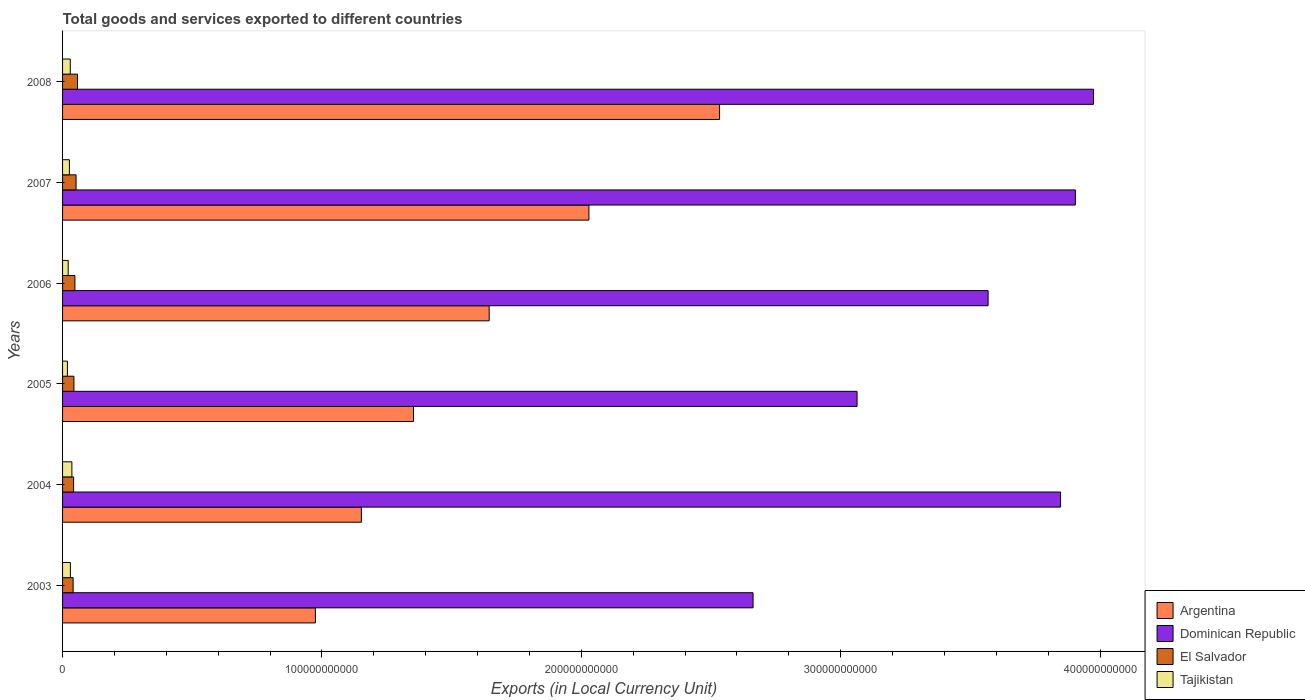How many different coloured bars are there?
Make the answer very short. 4. Are the number of bars per tick equal to the number of legend labels?
Your response must be concise. Yes. Are the number of bars on each tick of the Y-axis equal?
Keep it short and to the point. Yes. How many bars are there on the 2nd tick from the top?
Provide a short and direct response. 4. What is the label of the 3rd group of bars from the top?
Make the answer very short. 2006. What is the Amount of goods and services exports in El Salvador in 2007?
Your response must be concise. 5.20e+09. Across all years, what is the maximum Amount of goods and services exports in Dominican Republic?
Provide a succinct answer. 3.97e+11. Across all years, what is the minimum Amount of goods and services exports in El Salvador?
Offer a very short reply. 4.07e+09. What is the total Amount of goods and services exports in Tajikistan in the graph?
Offer a terse response. 1.63e+1. What is the difference between the Amount of goods and services exports in Dominican Republic in 2003 and that in 2005?
Offer a very short reply. -4.01e+1. What is the difference between the Amount of goods and services exports in El Salvador in 2005 and the Amount of goods and services exports in Argentina in 2007?
Ensure brevity in your answer.  -1.99e+11. What is the average Amount of goods and services exports in Tajikistan per year?
Provide a succinct answer. 2.71e+09. In the year 2007, what is the difference between the Amount of goods and services exports in Dominican Republic and Amount of goods and services exports in El Salvador?
Give a very brief answer. 3.85e+11. In how many years, is the Amount of goods and services exports in Tajikistan greater than 140000000000 LCU?
Ensure brevity in your answer.  0. What is the ratio of the Amount of goods and services exports in El Salvador in 2003 to that in 2005?
Ensure brevity in your answer.  0.93. What is the difference between the highest and the second highest Amount of goods and services exports in Argentina?
Your response must be concise. 5.04e+1. What is the difference between the highest and the lowest Amount of goods and services exports in Tajikistan?
Ensure brevity in your answer.  1.72e+09. In how many years, is the Amount of goods and services exports in Tajikistan greater than the average Amount of goods and services exports in Tajikistan taken over all years?
Your response must be concise. 3. Is the sum of the Amount of goods and services exports in Tajikistan in 2007 and 2008 greater than the maximum Amount of goods and services exports in El Salvador across all years?
Your response must be concise. No. What does the 2nd bar from the top in 2008 represents?
Make the answer very short. El Salvador. What does the 3rd bar from the bottom in 2003 represents?
Ensure brevity in your answer.  El Salvador. How many bars are there?
Make the answer very short. 24. How many years are there in the graph?
Your answer should be compact. 6. What is the difference between two consecutive major ticks on the X-axis?
Keep it short and to the point. 1.00e+11. Are the values on the major ticks of X-axis written in scientific E-notation?
Offer a terse response. No. What is the title of the graph?
Offer a terse response. Total goods and services exported to different countries. What is the label or title of the X-axis?
Give a very brief answer. Exports (in Local Currency Unit). What is the label or title of the Y-axis?
Your answer should be very brief. Years. What is the Exports (in Local Currency Unit) in Argentina in 2003?
Ensure brevity in your answer.  9.75e+1. What is the Exports (in Local Currency Unit) of Dominican Republic in 2003?
Provide a short and direct response. 2.66e+11. What is the Exports (in Local Currency Unit) of El Salvador in 2003?
Your answer should be compact. 4.07e+09. What is the Exports (in Local Currency Unit) of Tajikistan in 2003?
Your answer should be very brief. 3.02e+09. What is the Exports (in Local Currency Unit) of Argentina in 2004?
Make the answer very short. 1.15e+11. What is the Exports (in Local Currency Unit) in Dominican Republic in 2004?
Offer a terse response. 3.85e+11. What is the Exports (in Local Currency Unit) in El Salvador in 2004?
Ensure brevity in your answer.  4.26e+09. What is the Exports (in Local Currency Unit) in Tajikistan in 2004?
Offer a terse response. 3.60e+09. What is the Exports (in Local Currency Unit) in Argentina in 2005?
Provide a succinct answer. 1.35e+11. What is the Exports (in Local Currency Unit) in Dominican Republic in 2005?
Provide a short and direct response. 3.06e+11. What is the Exports (in Local Currency Unit) of El Salvador in 2005?
Give a very brief answer. 4.38e+09. What is the Exports (in Local Currency Unit) in Tajikistan in 2005?
Offer a very short reply. 1.87e+09. What is the Exports (in Local Currency Unit) in Argentina in 2006?
Offer a terse response. 1.64e+11. What is the Exports (in Local Currency Unit) in Dominican Republic in 2006?
Provide a succinct answer. 3.57e+11. What is the Exports (in Local Currency Unit) in El Salvador in 2006?
Offer a very short reply. 4.76e+09. What is the Exports (in Local Currency Unit) in Tajikistan in 2006?
Keep it short and to the point. 2.16e+09. What is the Exports (in Local Currency Unit) of Argentina in 2007?
Offer a terse response. 2.03e+11. What is the Exports (in Local Currency Unit) in Dominican Republic in 2007?
Your answer should be compact. 3.90e+11. What is the Exports (in Local Currency Unit) in El Salvador in 2007?
Ensure brevity in your answer.  5.20e+09. What is the Exports (in Local Currency Unit) in Tajikistan in 2007?
Make the answer very short. 2.64e+09. What is the Exports (in Local Currency Unit) of Argentina in 2008?
Your response must be concise. 2.53e+11. What is the Exports (in Local Currency Unit) of Dominican Republic in 2008?
Your response must be concise. 3.97e+11. What is the Exports (in Local Currency Unit) of El Salvador in 2008?
Your answer should be compact. 5.76e+09. What is the Exports (in Local Currency Unit) of Tajikistan in 2008?
Give a very brief answer. 2.97e+09. Across all years, what is the maximum Exports (in Local Currency Unit) of Argentina?
Provide a succinct answer. 2.53e+11. Across all years, what is the maximum Exports (in Local Currency Unit) of Dominican Republic?
Keep it short and to the point. 3.97e+11. Across all years, what is the maximum Exports (in Local Currency Unit) in El Salvador?
Provide a succinct answer. 5.76e+09. Across all years, what is the maximum Exports (in Local Currency Unit) in Tajikistan?
Give a very brief answer. 3.60e+09. Across all years, what is the minimum Exports (in Local Currency Unit) of Argentina?
Your answer should be very brief. 9.75e+1. Across all years, what is the minimum Exports (in Local Currency Unit) in Dominican Republic?
Your response must be concise. 2.66e+11. Across all years, what is the minimum Exports (in Local Currency Unit) of El Salvador?
Provide a succinct answer. 4.07e+09. Across all years, what is the minimum Exports (in Local Currency Unit) of Tajikistan?
Provide a short and direct response. 1.87e+09. What is the total Exports (in Local Currency Unit) of Argentina in the graph?
Provide a short and direct response. 9.69e+11. What is the total Exports (in Local Currency Unit) of Dominican Republic in the graph?
Provide a short and direct response. 2.10e+12. What is the total Exports (in Local Currency Unit) of El Salvador in the graph?
Your answer should be very brief. 2.84e+1. What is the total Exports (in Local Currency Unit) of Tajikistan in the graph?
Your answer should be compact. 1.63e+1. What is the difference between the Exports (in Local Currency Unit) in Argentina in 2003 and that in 2004?
Give a very brief answer. -1.77e+1. What is the difference between the Exports (in Local Currency Unit) in Dominican Republic in 2003 and that in 2004?
Your answer should be very brief. -1.19e+11. What is the difference between the Exports (in Local Currency Unit) of El Salvador in 2003 and that in 2004?
Provide a short and direct response. -1.86e+08. What is the difference between the Exports (in Local Currency Unit) in Tajikistan in 2003 and that in 2004?
Keep it short and to the point. -5.81e+08. What is the difference between the Exports (in Local Currency Unit) in Argentina in 2003 and that in 2005?
Provide a short and direct response. -3.78e+1. What is the difference between the Exports (in Local Currency Unit) in Dominican Republic in 2003 and that in 2005?
Offer a terse response. -4.01e+1. What is the difference between the Exports (in Local Currency Unit) of El Salvador in 2003 and that in 2005?
Your answer should be compact. -3.10e+08. What is the difference between the Exports (in Local Currency Unit) in Tajikistan in 2003 and that in 2005?
Keep it short and to the point. 1.14e+09. What is the difference between the Exports (in Local Currency Unit) in Argentina in 2003 and that in 2006?
Offer a very short reply. -6.70e+1. What is the difference between the Exports (in Local Currency Unit) in Dominican Republic in 2003 and that in 2006?
Offer a terse response. -9.06e+1. What is the difference between the Exports (in Local Currency Unit) in El Salvador in 2003 and that in 2006?
Give a very brief answer. -6.91e+08. What is the difference between the Exports (in Local Currency Unit) in Tajikistan in 2003 and that in 2006?
Offer a terse response. 8.51e+08. What is the difference between the Exports (in Local Currency Unit) of Argentina in 2003 and that in 2007?
Offer a terse response. -1.05e+11. What is the difference between the Exports (in Local Currency Unit) of Dominican Republic in 2003 and that in 2007?
Your answer should be very brief. -1.24e+11. What is the difference between the Exports (in Local Currency Unit) in El Salvador in 2003 and that in 2007?
Give a very brief answer. -1.13e+09. What is the difference between the Exports (in Local Currency Unit) in Tajikistan in 2003 and that in 2007?
Ensure brevity in your answer.  3.75e+08. What is the difference between the Exports (in Local Currency Unit) of Argentina in 2003 and that in 2008?
Give a very brief answer. -1.56e+11. What is the difference between the Exports (in Local Currency Unit) of Dominican Republic in 2003 and that in 2008?
Offer a very short reply. -1.31e+11. What is the difference between the Exports (in Local Currency Unit) of El Salvador in 2003 and that in 2008?
Offer a very short reply. -1.69e+09. What is the difference between the Exports (in Local Currency Unit) of Tajikistan in 2003 and that in 2008?
Your response must be concise. 4.79e+07. What is the difference between the Exports (in Local Currency Unit) of Argentina in 2004 and that in 2005?
Offer a very short reply. -2.01e+1. What is the difference between the Exports (in Local Currency Unit) of Dominican Republic in 2004 and that in 2005?
Provide a short and direct response. 7.85e+1. What is the difference between the Exports (in Local Currency Unit) in El Salvador in 2004 and that in 2005?
Keep it short and to the point. -1.24e+08. What is the difference between the Exports (in Local Currency Unit) in Tajikistan in 2004 and that in 2005?
Keep it short and to the point. 1.72e+09. What is the difference between the Exports (in Local Currency Unit) in Argentina in 2004 and that in 2006?
Provide a succinct answer. -4.93e+1. What is the difference between the Exports (in Local Currency Unit) in Dominican Republic in 2004 and that in 2006?
Your answer should be compact. 2.79e+1. What is the difference between the Exports (in Local Currency Unit) in El Salvador in 2004 and that in 2006?
Keep it short and to the point. -5.05e+08. What is the difference between the Exports (in Local Currency Unit) in Tajikistan in 2004 and that in 2006?
Provide a succinct answer. 1.43e+09. What is the difference between the Exports (in Local Currency Unit) of Argentina in 2004 and that in 2007?
Keep it short and to the point. -8.77e+1. What is the difference between the Exports (in Local Currency Unit) in Dominican Republic in 2004 and that in 2007?
Provide a succinct answer. -5.70e+09. What is the difference between the Exports (in Local Currency Unit) in El Salvador in 2004 and that in 2007?
Your answer should be compact. -9.45e+08. What is the difference between the Exports (in Local Currency Unit) of Tajikistan in 2004 and that in 2007?
Give a very brief answer. 9.56e+08. What is the difference between the Exports (in Local Currency Unit) of Argentina in 2004 and that in 2008?
Keep it short and to the point. -1.38e+11. What is the difference between the Exports (in Local Currency Unit) in Dominican Republic in 2004 and that in 2008?
Your answer should be compact. -1.27e+1. What is the difference between the Exports (in Local Currency Unit) of El Salvador in 2004 and that in 2008?
Offer a very short reply. -1.50e+09. What is the difference between the Exports (in Local Currency Unit) of Tajikistan in 2004 and that in 2008?
Keep it short and to the point. 6.29e+08. What is the difference between the Exports (in Local Currency Unit) in Argentina in 2005 and that in 2006?
Make the answer very short. -2.92e+1. What is the difference between the Exports (in Local Currency Unit) of Dominican Republic in 2005 and that in 2006?
Make the answer very short. -5.05e+1. What is the difference between the Exports (in Local Currency Unit) of El Salvador in 2005 and that in 2006?
Provide a succinct answer. -3.81e+08. What is the difference between the Exports (in Local Currency Unit) in Tajikistan in 2005 and that in 2006?
Provide a short and direct response. -2.91e+08. What is the difference between the Exports (in Local Currency Unit) of Argentina in 2005 and that in 2007?
Your response must be concise. -6.76e+1. What is the difference between the Exports (in Local Currency Unit) of Dominican Republic in 2005 and that in 2007?
Make the answer very short. -8.42e+1. What is the difference between the Exports (in Local Currency Unit) in El Salvador in 2005 and that in 2007?
Offer a very short reply. -8.21e+08. What is the difference between the Exports (in Local Currency Unit) of Tajikistan in 2005 and that in 2007?
Ensure brevity in your answer.  -7.66e+08. What is the difference between the Exports (in Local Currency Unit) of Argentina in 2005 and that in 2008?
Make the answer very short. -1.18e+11. What is the difference between the Exports (in Local Currency Unit) in Dominican Republic in 2005 and that in 2008?
Offer a very short reply. -9.12e+1. What is the difference between the Exports (in Local Currency Unit) of El Salvador in 2005 and that in 2008?
Offer a very short reply. -1.38e+09. What is the difference between the Exports (in Local Currency Unit) in Tajikistan in 2005 and that in 2008?
Your answer should be compact. -1.09e+09. What is the difference between the Exports (in Local Currency Unit) in Argentina in 2006 and that in 2007?
Your response must be concise. -3.84e+1. What is the difference between the Exports (in Local Currency Unit) in Dominican Republic in 2006 and that in 2007?
Offer a very short reply. -3.36e+1. What is the difference between the Exports (in Local Currency Unit) in El Salvador in 2006 and that in 2007?
Ensure brevity in your answer.  -4.40e+08. What is the difference between the Exports (in Local Currency Unit) in Tajikistan in 2006 and that in 2007?
Provide a succinct answer. -4.75e+08. What is the difference between the Exports (in Local Currency Unit) in Argentina in 2006 and that in 2008?
Offer a very short reply. -8.88e+1. What is the difference between the Exports (in Local Currency Unit) in Dominican Republic in 2006 and that in 2008?
Offer a very short reply. -4.06e+1. What is the difference between the Exports (in Local Currency Unit) of El Salvador in 2006 and that in 2008?
Offer a terse response. -9.97e+08. What is the difference between the Exports (in Local Currency Unit) of Tajikistan in 2006 and that in 2008?
Offer a terse response. -8.03e+08. What is the difference between the Exports (in Local Currency Unit) in Argentina in 2007 and that in 2008?
Your answer should be very brief. -5.04e+1. What is the difference between the Exports (in Local Currency Unit) of Dominican Republic in 2007 and that in 2008?
Give a very brief answer. -6.99e+09. What is the difference between the Exports (in Local Currency Unit) of El Salvador in 2007 and that in 2008?
Offer a very short reply. -5.57e+08. What is the difference between the Exports (in Local Currency Unit) of Tajikistan in 2007 and that in 2008?
Provide a short and direct response. -3.27e+08. What is the difference between the Exports (in Local Currency Unit) of Argentina in 2003 and the Exports (in Local Currency Unit) of Dominican Republic in 2004?
Keep it short and to the point. -2.87e+11. What is the difference between the Exports (in Local Currency Unit) of Argentina in 2003 and the Exports (in Local Currency Unit) of El Salvador in 2004?
Offer a very short reply. 9.32e+1. What is the difference between the Exports (in Local Currency Unit) in Argentina in 2003 and the Exports (in Local Currency Unit) in Tajikistan in 2004?
Your response must be concise. 9.39e+1. What is the difference between the Exports (in Local Currency Unit) of Dominican Republic in 2003 and the Exports (in Local Currency Unit) of El Salvador in 2004?
Keep it short and to the point. 2.62e+11. What is the difference between the Exports (in Local Currency Unit) of Dominican Republic in 2003 and the Exports (in Local Currency Unit) of Tajikistan in 2004?
Keep it short and to the point. 2.63e+11. What is the difference between the Exports (in Local Currency Unit) of El Salvador in 2003 and the Exports (in Local Currency Unit) of Tajikistan in 2004?
Your response must be concise. 4.77e+08. What is the difference between the Exports (in Local Currency Unit) of Argentina in 2003 and the Exports (in Local Currency Unit) of Dominican Republic in 2005?
Provide a short and direct response. -2.09e+11. What is the difference between the Exports (in Local Currency Unit) in Argentina in 2003 and the Exports (in Local Currency Unit) in El Salvador in 2005?
Your answer should be very brief. 9.31e+1. What is the difference between the Exports (in Local Currency Unit) in Argentina in 2003 and the Exports (in Local Currency Unit) in Tajikistan in 2005?
Your answer should be compact. 9.56e+1. What is the difference between the Exports (in Local Currency Unit) of Dominican Republic in 2003 and the Exports (in Local Currency Unit) of El Salvador in 2005?
Ensure brevity in your answer.  2.62e+11. What is the difference between the Exports (in Local Currency Unit) in Dominican Republic in 2003 and the Exports (in Local Currency Unit) in Tajikistan in 2005?
Keep it short and to the point. 2.64e+11. What is the difference between the Exports (in Local Currency Unit) of El Salvador in 2003 and the Exports (in Local Currency Unit) of Tajikistan in 2005?
Make the answer very short. 2.20e+09. What is the difference between the Exports (in Local Currency Unit) of Argentina in 2003 and the Exports (in Local Currency Unit) of Dominican Republic in 2006?
Offer a terse response. -2.59e+11. What is the difference between the Exports (in Local Currency Unit) of Argentina in 2003 and the Exports (in Local Currency Unit) of El Salvador in 2006?
Offer a terse response. 9.27e+1. What is the difference between the Exports (in Local Currency Unit) in Argentina in 2003 and the Exports (in Local Currency Unit) in Tajikistan in 2006?
Your response must be concise. 9.53e+1. What is the difference between the Exports (in Local Currency Unit) of Dominican Republic in 2003 and the Exports (in Local Currency Unit) of El Salvador in 2006?
Give a very brief answer. 2.61e+11. What is the difference between the Exports (in Local Currency Unit) of Dominican Republic in 2003 and the Exports (in Local Currency Unit) of Tajikistan in 2006?
Make the answer very short. 2.64e+11. What is the difference between the Exports (in Local Currency Unit) in El Salvador in 2003 and the Exports (in Local Currency Unit) in Tajikistan in 2006?
Your answer should be compact. 1.91e+09. What is the difference between the Exports (in Local Currency Unit) in Argentina in 2003 and the Exports (in Local Currency Unit) in Dominican Republic in 2007?
Keep it short and to the point. -2.93e+11. What is the difference between the Exports (in Local Currency Unit) in Argentina in 2003 and the Exports (in Local Currency Unit) in El Salvador in 2007?
Offer a very short reply. 9.23e+1. What is the difference between the Exports (in Local Currency Unit) in Argentina in 2003 and the Exports (in Local Currency Unit) in Tajikistan in 2007?
Offer a very short reply. 9.48e+1. What is the difference between the Exports (in Local Currency Unit) in Dominican Republic in 2003 and the Exports (in Local Currency Unit) in El Salvador in 2007?
Your response must be concise. 2.61e+11. What is the difference between the Exports (in Local Currency Unit) in Dominican Republic in 2003 and the Exports (in Local Currency Unit) in Tajikistan in 2007?
Your answer should be very brief. 2.64e+11. What is the difference between the Exports (in Local Currency Unit) in El Salvador in 2003 and the Exports (in Local Currency Unit) in Tajikistan in 2007?
Your response must be concise. 1.43e+09. What is the difference between the Exports (in Local Currency Unit) in Argentina in 2003 and the Exports (in Local Currency Unit) in Dominican Republic in 2008?
Offer a very short reply. -3.00e+11. What is the difference between the Exports (in Local Currency Unit) of Argentina in 2003 and the Exports (in Local Currency Unit) of El Salvador in 2008?
Your answer should be very brief. 9.17e+1. What is the difference between the Exports (in Local Currency Unit) of Argentina in 2003 and the Exports (in Local Currency Unit) of Tajikistan in 2008?
Provide a succinct answer. 9.45e+1. What is the difference between the Exports (in Local Currency Unit) of Dominican Republic in 2003 and the Exports (in Local Currency Unit) of El Salvador in 2008?
Your answer should be compact. 2.60e+11. What is the difference between the Exports (in Local Currency Unit) in Dominican Republic in 2003 and the Exports (in Local Currency Unit) in Tajikistan in 2008?
Provide a succinct answer. 2.63e+11. What is the difference between the Exports (in Local Currency Unit) in El Salvador in 2003 and the Exports (in Local Currency Unit) in Tajikistan in 2008?
Provide a short and direct response. 1.11e+09. What is the difference between the Exports (in Local Currency Unit) in Argentina in 2004 and the Exports (in Local Currency Unit) in Dominican Republic in 2005?
Give a very brief answer. -1.91e+11. What is the difference between the Exports (in Local Currency Unit) in Argentina in 2004 and the Exports (in Local Currency Unit) in El Salvador in 2005?
Offer a very short reply. 1.11e+11. What is the difference between the Exports (in Local Currency Unit) in Argentina in 2004 and the Exports (in Local Currency Unit) in Tajikistan in 2005?
Offer a very short reply. 1.13e+11. What is the difference between the Exports (in Local Currency Unit) in Dominican Republic in 2004 and the Exports (in Local Currency Unit) in El Salvador in 2005?
Ensure brevity in your answer.  3.80e+11. What is the difference between the Exports (in Local Currency Unit) of Dominican Republic in 2004 and the Exports (in Local Currency Unit) of Tajikistan in 2005?
Give a very brief answer. 3.83e+11. What is the difference between the Exports (in Local Currency Unit) in El Salvador in 2004 and the Exports (in Local Currency Unit) in Tajikistan in 2005?
Your answer should be very brief. 2.39e+09. What is the difference between the Exports (in Local Currency Unit) in Argentina in 2004 and the Exports (in Local Currency Unit) in Dominican Republic in 2006?
Your answer should be compact. -2.42e+11. What is the difference between the Exports (in Local Currency Unit) in Argentina in 2004 and the Exports (in Local Currency Unit) in El Salvador in 2006?
Your response must be concise. 1.10e+11. What is the difference between the Exports (in Local Currency Unit) of Argentina in 2004 and the Exports (in Local Currency Unit) of Tajikistan in 2006?
Make the answer very short. 1.13e+11. What is the difference between the Exports (in Local Currency Unit) of Dominican Republic in 2004 and the Exports (in Local Currency Unit) of El Salvador in 2006?
Your response must be concise. 3.80e+11. What is the difference between the Exports (in Local Currency Unit) of Dominican Republic in 2004 and the Exports (in Local Currency Unit) of Tajikistan in 2006?
Keep it short and to the point. 3.83e+11. What is the difference between the Exports (in Local Currency Unit) of El Salvador in 2004 and the Exports (in Local Currency Unit) of Tajikistan in 2006?
Your response must be concise. 2.09e+09. What is the difference between the Exports (in Local Currency Unit) in Argentina in 2004 and the Exports (in Local Currency Unit) in Dominican Republic in 2007?
Provide a succinct answer. -2.75e+11. What is the difference between the Exports (in Local Currency Unit) in Argentina in 2004 and the Exports (in Local Currency Unit) in El Salvador in 2007?
Your answer should be very brief. 1.10e+11. What is the difference between the Exports (in Local Currency Unit) of Argentina in 2004 and the Exports (in Local Currency Unit) of Tajikistan in 2007?
Ensure brevity in your answer.  1.13e+11. What is the difference between the Exports (in Local Currency Unit) in Dominican Republic in 2004 and the Exports (in Local Currency Unit) in El Salvador in 2007?
Ensure brevity in your answer.  3.80e+11. What is the difference between the Exports (in Local Currency Unit) of Dominican Republic in 2004 and the Exports (in Local Currency Unit) of Tajikistan in 2007?
Offer a very short reply. 3.82e+11. What is the difference between the Exports (in Local Currency Unit) of El Salvador in 2004 and the Exports (in Local Currency Unit) of Tajikistan in 2007?
Provide a succinct answer. 1.62e+09. What is the difference between the Exports (in Local Currency Unit) in Argentina in 2004 and the Exports (in Local Currency Unit) in Dominican Republic in 2008?
Provide a succinct answer. -2.82e+11. What is the difference between the Exports (in Local Currency Unit) in Argentina in 2004 and the Exports (in Local Currency Unit) in El Salvador in 2008?
Keep it short and to the point. 1.09e+11. What is the difference between the Exports (in Local Currency Unit) in Argentina in 2004 and the Exports (in Local Currency Unit) in Tajikistan in 2008?
Make the answer very short. 1.12e+11. What is the difference between the Exports (in Local Currency Unit) of Dominican Republic in 2004 and the Exports (in Local Currency Unit) of El Salvador in 2008?
Provide a short and direct response. 3.79e+11. What is the difference between the Exports (in Local Currency Unit) of Dominican Republic in 2004 and the Exports (in Local Currency Unit) of Tajikistan in 2008?
Provide a short and direct response. 3.82e+11. What is the difference between the Exports (in Local Currency Unit) of El Salvador in 2004 and the Exports (in Local Currency Unit) of Tajikistan in 2008?
Provide a succinct answer. 1.29e+09. What is the difference between the Exports (in Local Currency Unit) in Argentina in 2005 and the Exports (in Local Currency Unit) in Dominican Republic in 2006?
Provide a short and direct response. -2.22e+11. What is the difference between the Exports (in Local Currency Unit) in Argentina in 2005 and the Exports (in Local Currency Unit) in El Salvador in 2006?
Give a very brief answer. 1.31e+11. What is the difference between the Exports (in Local Currency Unit) in Argentina in 2005 and the Exports (in Local Currency Unit) in Tajikistan in 2006?
Ensure brevity in your answer.  1.33e+11. What is the difference between the Exports (in Local Currency Unit) of Dominican Republic in 2005 and the Exports (in Local Currency Unit) of El Salvador in 2006?
Make the answer very short. 3.02e+11. What is the difference between the Exports (in Local Currency Unit) of Dominican Republic in 2005 and the Exports (in Local Currency Unit) of Tajikistan in 2006?
Provide a succinct answer. 3.04e+11. What is the difference between the Exports (in Local Currency Unit) of El Salvador in 2005 and the Exports (in Local Currency Unit) of Tajikistan in 2006?
Your answer should be very brief. 2.22e+09. What is the difference between the Exports (in Local Currency Unit) of Argentina in 2005 and the Exports (in Local Currency Unit) of Dominican Republic in 2007?
Provide a succinct answer. -2.55e+11. What is the difference between the Exports (in Local Currency Unit) of Argentina in 2005 and the Exports (in Local Currency Unit) of El Salvador in 2007?
Make the answer very short. 1.30e+11. What is the difference between the Exports (in Local Currency Unit) of Argentina in 2005 and the Exports (in Local Currency Unit) of Tajikistan in 2007?
Provide a short and direct response. 1.33e+11. What is the difference between the Exports (in Local Currency Unit) of Dominican Republic in 2005 and the Exports (in Local Currency Unit) of El Salvador in 2007?
Provide a succinct answer. 3.01e+11. What is the difference between the Exports (in Local Currency Unit) in Dominican Republic in 2005 and the Exports (in Local Currency Unit) in Tajikistan in 2007?
Your answer should be compact. 3.04e+11. What is the difference between the Exports (in Local Currency Unit) of El Salvador in 2005 and the Exports (in Local Currency Unit) of Tajikistan in 2007?
Make the answer very short. 1.74e+09. What is the difference between the Exports (in Local Currency Unit) of Argentina in 2005 and the Exports (in Local Currency Unit) of Dominican Republic in 2008?
Give a very brief answer. -2.62e+11. What is the difference between the Exports (in Local Currency Unit) in Argentina in 2005 and the Exports (in Local Currency Unit) in El Salvador in 2008?
Give a very brief answer. 1.30e+11. What is the difference between the Exports (in Local Currency Unit) in Argentina in 2005 and the Exports (in Local Currency Unit) in Tajikistan in 2008?
Keep it short and to the point. 1.32e+11. What is the difference between the Exports (in Local Currency Unit) of Dominican Republic in 2005 and the Exports (in Local Currency Unit) of El Salvador in 2008?
Your response must be concise. 3.01e+11. What is the difference between the Exports (in Local Currency Unit) in Dominican Republic in 2005 and the Exports (in Local Currency Unit) in Tajikistan in 2008?
Ensure brevity in your answer.  3.03e+11. What is the difference between the Exports (in Local Currency Unit) of El Salvador in 2005 and the Exports (in Local Currency Unit) of Tajikistan in 2008?
Your answer should be compact. 1.42e+09. What is the difference between the Exports (in Local Currency Unit) of Argentina in 2006 and the Exports (in Local Currency Unit) of Dominican Republic in 2007?
Your answer should be compact. -2.26e+11. What is the difference between the Exports (in Local Currency Unit) in Argentina in 2006 and the Exports (in Local Currency Unit) in El Salvador in 2007?
Offer a terse response. 1.59e+11. What is the difference between the Exports (in Local Currency Unit) in Argentina in 2006 and the Exports (in Local Currency Unit) in Tajikistan in 2007?
Offer a very short reply. 1.62e+11. What is the difference between the Exports (in Local Currency Unit) in Dominican Republic in 2006 and the Exports (in Local Currency Unit) in El Salvador in 2007?
Your response must be concise. 3.52e+11. What is the difference between the Exports (in Local Currency Unit) in Dominican Republic in 2006 and the Exports (in Local Currency Unit) in Tajikistan in 2007?
Your answer should be very brief. 3.54e+11. What is the difference between the Exports (in Local Currency Unit) in El Salvador in 2006 and the Exports (in Local Currency Unit) in Tajikistan in 2007?
Give a very brief answer. 2.12e+09. What is the difference between the Exports (in Local Currency Unit) of Argentina in 2006 and the Exports (in Local Currency Unit) of Dominican Republic in 2008?
Keep it short and to the point. -2.33e+11. What is the difference between the Exports (in Local Currency Unit) in Argentina in 2006 and the Exports (in Local Currency Unit) in El Salvador in 2008?
Give a very brief answer. 1.59e+11. What is the difference between the Exports (in Local Currency Unit) in Argentina in 2006 and the Exports (in Local Currency Unit) in Tajikistan in 2008?
Your response must be concise. 1.62e+11. What is the difference between the Exports (in Local Currency Unit) of Dominican Republic in 2006 and the Exports (in Local Currency Unit) of El Salvador in 2008?
Keep it short and to the point. 3.51e+11. What is the difference between the Exports (in Local Currency Unit) in Dominican Republic in 2006 and the Exports (in Local Currency Unit) in Tajikistan in 2008?
Your answer should be compact. 3.54e+11. What is the difference between the Exports (in Local Currency Unit) in El Salvador in 2006 and the Exports (in Local Currency Unit) in Tajikistan in 2008?
Your answer should be very brief. 1.80e+09. What is the difference between the Exports (in Local Currency Unit) in Argentina in 2007 and the Exports (in Local Currency Unit) in Dominican Republic in 2008?
Offer a very short reply. -1.95e+11. What is the difference between the Exports (in Local Currency Unit) of Argentina in 2007 and the Exports (in Local Currency Unit) of El Salvador in 2008?
Give a very brief answer. 1.97e+11. What is the difference between the Exports (in Local Currency Unit) in Argentina in 2007 and the Exports (in Local Currency Unit) in Tajikistan in 2008?
Offer a terse response. 2.00e+11. What is the difference between the Exports (in Local Currency Unit) in Dominican Republic in 2007 and the Exports (in Local Currency Unit) in El Salvador in 2008?
Offer a terse response. 3.85e+11. What is the difference between the Exports (in Local Currency Unit) in Dominican Republic in 2007 and the Exports (in Local Currency Unit) in Tajikistan in 2008?
Offer a very short reply. 3.88e+11. What is the difference between the Exports (in Local Currency Unit) in El Salvador in 2007 and the Exports (in Local Currency Unit) in Tajikistan in 2008?
Your response must be concise. 2.24e+09. What is the average Exports (in Local Currency Unit) of Argentina per year?
Make the answer very short. 1.61e+11. What is the average Exports (in Local Currency Unit) of Dominican Republic per year?
Make the answer very short. 3.50e+11. What is the average Exports (in Local Currency Unit) of El Salvador per year?
Your answer should be compact. 4.74e+09. What is the average Exports (in Local Currency Unit) in Tajikistan per year?
Your response must be concise. 2.71e+09. In the year 2003, what is the difference between the Exports (in Local Currency Unit) in Argentina and Exports (in Local Currency Unit) in Dominican Republic?
Ensure brevity in your answer.  -1.69e+11. In the year 2003, what is the difference between the Exports (in Local Currency Unit) of Argentina and Exports (in Local Currency Unit) of El Salvador?
Give a very brief answer. 9.34e+1. In the year 2003, what is the difference between the Exports (in Local Currency Unit) of Argentina and Exports (in Local Currency Unit) of Tajikistan?
Your answer should be very brief. 9.45e+1. In the year 2003, what is the difference between the Exports (in Local Currency Unit) in Dominican Republic and Exports (in Local Currency Unit) in El Salvador?
Provide a short and direct response. 2.62e+11. In the year 2003, what is the difference between the Exports (in Local Currency Unit) in Dominican Republic and Exports (in Local Currency Unit) in Tajikistan?
Keep it short and to the point. 2.63e+11. In the year 2003, what is the difference between the Exports (in Local Currency Unit) in El Salvador and Exports (in Local Currency Unit) in Tajikistan?
Keep it short and to the point. 1.06e+09. In the year 2004, what is the difference between the Exports (in Local Currency Unit) in Argentina and Exports (in Local Currency Unit) in Dominican Republic?
Offer a terse response. -2.70e+11. In the year 2004, what is the difference between the Exports (in Local Currency Unit) in Argentina and Exports (in Local Currency Unit) in El Salvador?
Provide a succinct answer. 1.11e+11. In the year 2004, what is the difference between the Exports (in Local Currency Unit) of Argentina and Exports (in Local Currency Unit) of Tajikistan?
Keep it short and to the point. 1.12e+11. In the year 2004, what is the difference between the Exports (in Local Currency Unit) in Dominican Republic and Exports (in Local Currency Unit) in El Salvador?
Provide a short and direct response. 3.81e+11. In the year 2004, what is the difference between the Exports (in Local Currency Unit) of Dominican Republic and Exports (in Local Currency Unit) of Tajikistan?
Keep it short and to the point. 3.81e+11. In the year 2004, what is the difference between the Exports (in Local Currency Unit) in El Salvador and Exports (in Local Currency Unit) in Tajikistan?
Make the answer very short. 6.63e+08. In the year 2005, what is the difference between the Exports (in Local Currency Unit) of Argentina and Exports (in Local Currency Unit) of Dominican Republic?
Your answer should be compact. -1.71e+11. In the year 2005, what is the difference between the Exports (in Local Currency Unit) of Argentina and Exports (in Local Currency Unit) of El Salvador?
Provide a short and direct response. 1.31e+11. In the year 2005, what is the difference between the Exports (in Local Currency Unit) of Argentina and Exports (in Local Currency Unit) of Tajikistan?
Provide a succinct answer. 1.33e+11. In the year 2005, what is the difference between the Exports (in Local Currency Unit) in Dominican Republic and Exports (in Local Currency Unit) in El Salvador?
Offer a terse response. 3.02e+11. In the year 2005, what is the difference between the Exports (in Local Currency Unit) of Dominican Republic and Exports (in Local Currency Unit) of Tajikistan?
Give a very brief answer. 3.04e+11. In the year 2005, what is the difference between the Exports (in Local Currency Unit) in El Salvador and Exports (in Local Currency Unit) in Tajikistan?
Provide a short and direct response. 2.51e+09. In the year 2006, what is the difference between the Exports (in Local Currency Unit) in Argentina and Exports (in Local Currency Unit) in Dominican Republic?
Your response must be concise. -1.92e+11. In the year 2006, what is the difference between the Exports (in Local Currency Unit) in Argentina and Exports (in Local Currency Unit) in El Salvador?
Your answer should be very brief. 1.60e+11. In the year 2006, what is the difference between the Exports (in Local Currency Unit) of Argentina and Exports (in Local Currency Unit) of Tajikistan?
Offer a very short reply. 1.62e+11. In the year 2006, what is the difference between the Exports (in Local Currency Unit) in Dominican Republic and Exports (in Local Currency Unit) in El Salvador?
Your response must be concise. 3.52e+11. In the year 2006, what is the difference between the Exports (in Local Currency Unit) in Dominican Republic and Exports (in Local Currency Unit) in Tajikistan?
Ensure brevity in your answer.  3.55e+11. In the year 2006, what is the difference between the Exports (in Local Currency Unit) of El Salvador and Exports (in Local Currency Unit) of Tajikistan?
Your response must be concise. 2.60e+09. In the year 2007, what is the difference between the Exports (in Local Currency Unit) of Argentina and Exports (in Local Currency Unit) of Dominican Republic?
Provide a short and direct response. -1.88e+11. In the year 2007, what is the difference between the Exports (in Local Currency Unit) of Argentina and Exports (in Local Currency Unit) of El Salvador?
Make the answer very short. 1.98e+11. In the year 2007, what is the difference between the Exports (in Local Currency Unit) of Argentina and Exports (in Local Currency Unit) of Tajikistan?
Your answer should be very brief. 2.00e+11. In the year 2007, what is the difference between the Exports (in Local Currency Unit) of Dominican Republic and Exports (in Local Currency Unit) of El Salvador?
Offer a terse response. 3.85e+11. In the year 2007, what is the difference between the Exports (in Local Currency Unit) in Dominican Republic and Exports (in Local Currency Unit) in Tajikistan?
Provide a short and direct response. 3.88e+11. In the year 2007, what is the difference between the Exports (in Local Currency Unit) in El Salvador and Exports (in Local Currency Unit) in Tajikistan?
Offer a terse response. 2.56e+09. In the year 2008, what is the difference between the Exports (in Local Currency Unit) of Argentina and Exports (in Local Currency Unit) of Dominican Republic?
Ensure brevity in your answer.  -1.44e+11. In the year 2008, what is the difference between the Exports (in Local Currency Unit) of Argentina and Exports (in Local Currency Unit) of El Salvador?
Provide a succinct answer. 2.48e+11. In the year 2008, what is the difference between the Exports (in Local Currency Unit) in Argentina and Exports (in Local Currency Unit) in Tajikistan?
Offer a very short reply. 2.50e+11. In the year 2008, what is the difference between the Exports (in Local Currency Unit) in Dominican Republic and Exports (in Local Currency Unit) in El Salvador?
Your response must be concise. 3.92e+11. In the year 2008, what is the difference between the Exports (in Local Currency Unit) of Dominican Republic and Exports (in Local Currency Unit) of Tajikistan?
Offer a terse response. 3.95e+11. In the year 2008, what is the difference between the Exports (in Local Currency Unit) of El Salvador and Exports (in Local Currency Unit) of Tajikistan?
Your response must be concise. 2.79e+09. What is the ratio of the Exports (in Local Currency Unit) in Argentina in 2003 to that in 2004?
Give a very brief answer. 0.85. What is the ratio of the Exports (in Local Currency Unit) of Dominican Republic in 2003 to that in 2004?
Offer a terse response. 0.69. What is the ratio of the Exports (in Local Currency Unit) in El Salvador in 2003 to that in 2004?
Keep it short and to the point. 0.96. What is the ratio of the Exports (in Local Currency Unit) of Tajikistan in 2003 to that in 2004?
Make the answer very short. 0.84. What is the ratio of the Exports (in Local Currency Unit) in Argentina in 2003 to that in 2005?
Ensure brevity in your answer.  0.72. What is the ratio of the Exports (in Local Currency Unit) in Dominican Republic in 2003 to that in 2005?
Offer a terse response. 0.87. What is the ratio of the Exports (in Local Currency Unit) in El Salvador in 2003 to that in 2005?
Keep it short and to the point. 0.93. What is the ratio of the Exports (in Local Currency Unit) of Tajikistan in 2003 to that in 2005?
Your answer should be very brief. 1.61. What is the ratio of the Exports (in Local Currency Unit) in Argentina in 2003 to that in 2006?
Your answer should be very brief. 0.59. What is the ratio of the Exports (in Local Currency Unit) of Dominican Republic in 2003 to that in 2006?
Offer a very short reply. 0.75. What is the ratio of the Exports (in Local Currency Unit) of El Salvador in 2003 to that in 2006?
Your answer should be very brief. 0.85. What is the ratio of the Exports (in Local Currency Unit) of Tajikistan in 2003 to that in 2006?
Give a very brief answer. 1.39. What is the ratio of the Exports (in Local Currency Unit) in Argentina in 2003 to that in 2007?
Give a very brief answer. 0.48. What is the ratio of the Exports (in Local Currency Unit) of Dominican Republic in 2003 to that in 2007?
Offer a very short reply. 0.68. What is the ratio of the Exports (in Local Currency Unit) in El Salvador in 2003 to that in 2007?
Your response must be concise. 0.78. What is the ratio of the Exports (in Local Currency Unit) of Tajikistan in 2003 to that in 2007?
Offer a terse response. 1.14. What is the ratio of the Exports (in Local Currency Unit) of Argentina in 2003 to that in 2008?
Offer a very short reply. 0.38. What is the ratio of the Exports (in Local Currency Unit) in Dominican Republic in 2003 to that in 2008?
Provide a short and direct response. 0.67. What is the ratio of the Exports (in Local Currency Unit) in El Salvador in 2003 to that in 2008?
Your answer should be compact. 0.71. What is the ratio of the Exports (in Local Currency Unit) in Tajikistan in 2003 to that in 2008?
Provide a short and direct response. 1.02. What is the ratio of the Exports (in Local Currency Unit) in Argentina in 2004 to that in 2005?
Offer a terse response. 0.85. What is the ratio of the Exports (in Local Currency Unit) of Dominican Republic in 2004 to that in 2005?
Offer a terse response. 1.26. What is the ratio of the Exports (in Local Currency Unit) of El Salvador in 2004 to that in 2005?
Make the answer very short. 0.97. What is the ratio of the Exports (in Local Currency Unit) in Tajikistan in 2004 to that in 2005?
Your response must be concise. 1.92. What is the ratio of the Exports (in Local Currency Unit) of Argentina in 2004 to that in 2006?
Offer a very short reply. 0.7. What is the ratio of the Exports (in Local Currency Unit) in Dominican Republic in 2004 to that in 2006?
Make the answer very short. 1.08. What is the ratio of the Exports (in Local Currency Unit) of El Salvador in 2004 to that in 2006?
Your response must be concise. 0.89. What is the ratio of the Exports (in Local Currency Unit) of Tajikistan in 2004 to that in 2006?
Offer a terse response. 1.66. What is the ratio of the Exports (in Local Currency Unit) of Argentina in 2004 to that in 2007?
Provide a succinct answer. 0.57. What is the ratio of the Exports (in Local Currency Unit) of Dominican Republic in 2004 to that in 2007?
Offer a very short reply. 0.99. What is the ratio of the Exports (in Local Currency Unit) in El Salvador in 2004 to that in 2007?
Your response must be concise. 0.82. What is the ratio of the Exports (in Local Currency Unit) in Tajikistan in 2004 to that in 2007?
Keep it short and to the point. 1.36. What is the ratio of the Exports (in Local Currency Unit) in Argentina in 2004 to that in 2008?
Offer a very short reply. 0.45. What is the ratio of the Exports (in Local Currency Unit) in Dominican Republic in 2004 to that in 2008?
Provide a succinct answer. 0.97. What is the ratio of the Exports (in Local Currency Unit) of El Salvador in 2004 to that in 2008?
Provide a short and direct response. 0.74. What is the ratio of the Exports (in Local Currency Unit) of Tajikistan in 2004 to that in 2008?
Keep it short and to the point. 1.21. What is the ratio of the Exports (in Local Currency Unit) of Argentina in 2005 to that in 2006?
Ensure brevity in your answer.  0.82. What is the ratio of the Exports (in Local Currency Unit) of Dominican Republic in 2005 to that in 2006?
Offer a very short reply. 0.86. What is the ratio of the Exports (in Local Currency Unit) in El Salvador in 2005 to that in 2006?
Offer a very short reply. 0.92. What is the ratio of the Exports (in Local Currency Unit) of Tajikistan in 2005 to that in 2006?
Ensure brevity in your answer.  0.87. What is the ratio of the Exports (in Local Currency Unit) of Argentina in 2005 to that in 2007?
Keep it short and to the point. 0.67. What is the ratio of the Exports (in Local Currency Unit) in Dominican Republic in 2005 to that in 2007?
Offer a very short reply. 0.78. What is the ratio of the Exports (in Local Currency Unit) of El Salvador in 2005 to that in 2007?
Your answer should be very brief. 0.84. What is the ratio of the Exports (in Local Currency Unit) in Tajikistan in 2005 to that in 2007?
Make the answer very short. 0.71. What is the ratio of the Exports (in Local Currency Unit) in Argentina in 2005 to that in 2008?
Your response must be concise. 0.53. What is the ratio of the Exports (in Local Currency Unit) in Dominican Republic in 2005 to that in 2008?
Ensure brevity in your answer.  0.77. What is the ratio of the Exports (in Local Currency Unit) in El Salvador in 2005 to that in 2008?
Ensure brevity in your answer.  0.76. What is the ratio of the Exports (in Local Currency Unit) in Tajikistan in 2005 to that in 2008?
Make the answer very short. 0.63. What is the ratio of the Exports (in Local Currency Unit) of Argentina in 2006 to that in 2007?
Provide a succinct answer. 0.81. What is the ratio of the Exports (in Local Currency Unit) of Dominican Republic in 2006 to that in 2007?
Give a very brief answer. 0.91. What is the ratio of the Exports (in Local Currency Unit) of El Salvador in 2006 to that in 2007?
Keep it short and to the point. 0.92. What is the ratio of the Exports (in Local Currency Unit) in Tajikistan in 2006 to that in 2007?
Your answer should be compact. 0.82. What is the ratio of the Exports (in Local Currency Unit) in Argentina in 2006 to that in 2008?
Offer a very short reply. 0.65. What is the ratio of the Exports (in Local Currency Unit) of Dominican Republic in 2006 to that in 2008?
Make the answer very short. 0.9. What is the ratio of the Exports (in Local Currency Unit) of El Salvador in 2006 to that in 2008?
Your answer should be very brief. 0.83. What is the ratio of the Exports (in Local Currency Unit) of Tajikistan in 2006 to that in 2008?
Provide a succinct answer. 0.73. What is the ratio of the Exports (in Local Currency Unit) in Argentina in 2007 to that in 2008?
Ensure brevity in your answer.  0.8. What is the ratio of the Exports (in Local Currency Unit) in Dominican Republic in 2007 to that in 2008?
Give a very brief answer. 0.98. What is the ratio of the Exports (in Local Currency Unit) in El Salvador in 2007 to that in 2008?
Give a very brief answer. 0.9. What is the ratio of the Exports (in Local Currency Unit) of Tajikistan in 2007 to that in 2008?
Provide a succinct answer. 0.89. What is the difference between the highest and the second highest Exports (in Local Currency Unit) of Argentina?
Your answer should be very brief. 5.04e+1. What is the difference between the highest and the second highest Exports (in Local Currency Unit) of Dominican Republic?
Make the answer very short. 6.99e+09. What is the difference between the highest and the second highest Exports (in Local Currency Unit) in El Salvador?
Keep it short and to the point. 5.57e+08. What is the difference between the highest and the second highest Exports (in Local Currency Unit) in Tajikistan?
Offer a terse response. 5.81e+08. What is the difference between the highest and the lowest Exports (in Local Currency Unit) of Argentina?
Offer a very short reply. 1.56e+11. What is the difference between the highest and the lowest Exports (in Local Currency Unit) of Dominican Republic?
Provide a succinct answer. 1.31e+11. What is the difference between the highest and the lowest Exports (in Local Currency Unit) of El Salvador?
Offer a terse response. 1.69e+09. What is the difference between the highest and the lowest Exports (in Local Currency Unit) of Tajikistan?
Ensure brevity in your answer.  1.72e+09. 